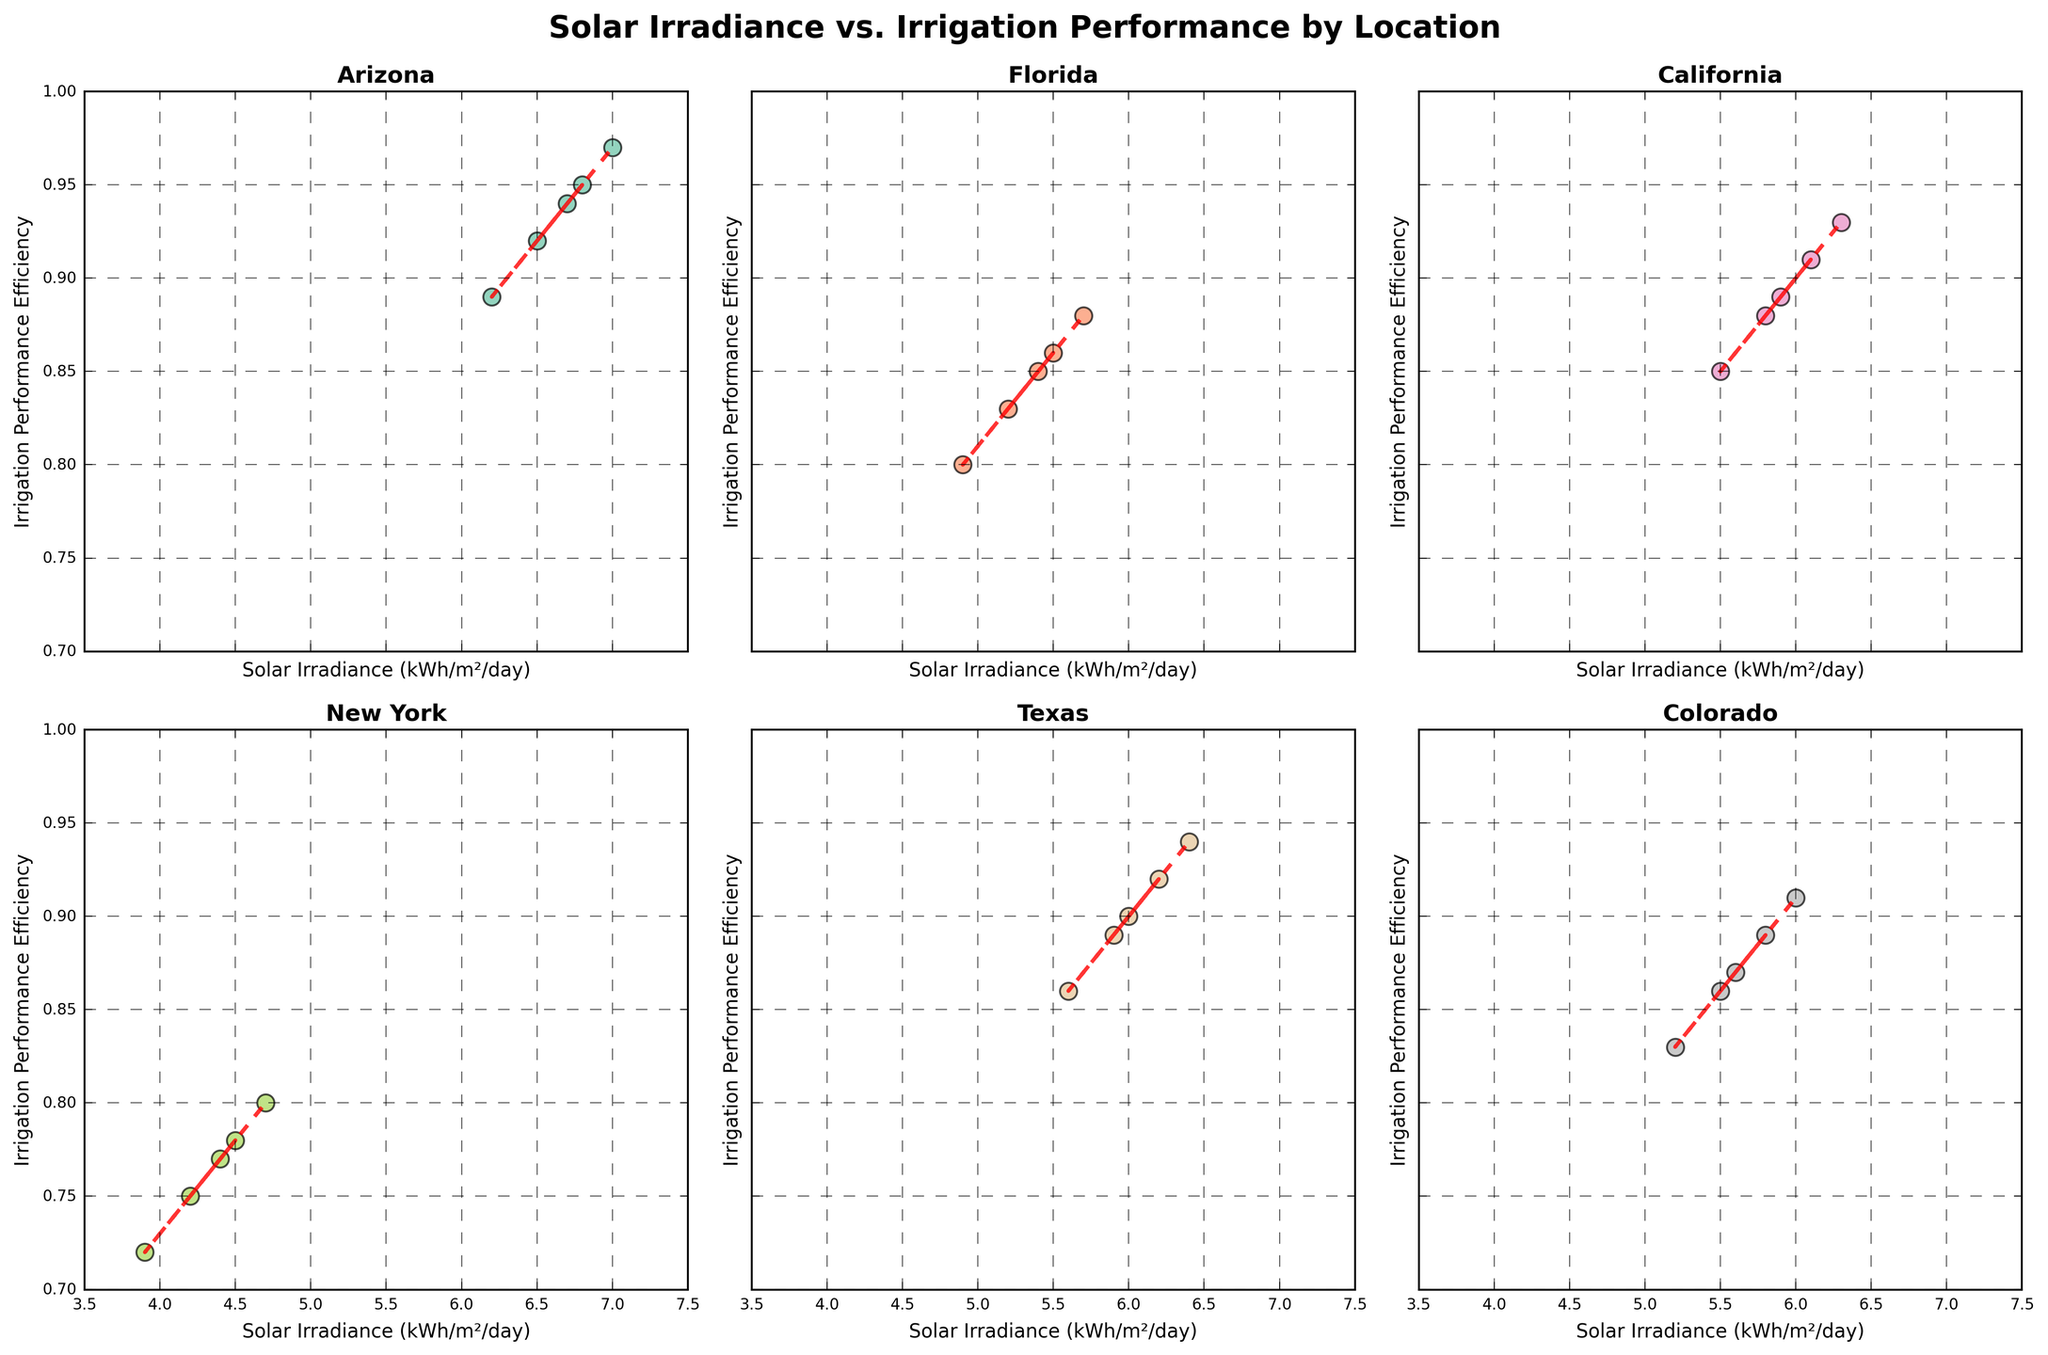Which location shows the highest range of irrigation performance efficiency? The highest range of irrigation performance efficiency is determined by finding the difference between the maximum and minimum efficiency values for each location. Arizona has a range from 0.89 to 0.97, which is 0.08, and the other ranges for locations are less than this.
Answer: Arizona In which location does the solar irradiance correlate most strongly with irrigation performance efficiency? The correlation strength can be judged by the slope and closeness of the points to the trend line. Arizona shows a strong positive trend with points close to the trend line.
Answer: Arizona Which location has the lowest minimum value of solar irradiance? Checking each subplot, New York shows values starting as low as 3.9 kWh/m²/day, which is the lowest minimum among all locations.
Answer: New York Which location exhibits the least variability in irrigation performance efficiency? Least variability can be assessed by observing the spread of the irrigation performance efficiency values. California shows closely packed efficiency values between 0.85 and 0.93, indicating the least variability.
Answer: California Compare the average solar irradiance between Florida and Colorado. Which one is higher? To compare the average solar irradiance, we calculate the mean value of solar irradiance for both locations. For Florida, it is (5.2+5.5+4.9+5.7+5.4)/5 = 5.34 kWh/m²/day. For Colorado, it is (5.5+5.8+5.2+6.0+5.6)/5 = 5.62 kWh/m²/day. Hence, Colorado has a higher average solar irradiance.
Answer: Colorado Which location has the steepest trend line (indicating the strongest linear relationship)? By observing the angle and steepness of the trend lines in the subplots, Arizona's trend line appears the steepest, suggesting Arizona has the strongest linear relationship.
Answer: Arizona Which locations have overlapping ranges of irrigation performance efficiency? Looking at the irrigation performance efficiency values, Florida and California have overlapping ranges (0.80 to 0.88 for Florida and 0.85 to 0.93 for California).
Answer: Florida and California How does the trend line for New York differ from that of Texas? New York's trend line has a gentle incline, indicating a weaker positive relationship, while Texas shows a steeper trend line, indicating a stronger positive correlation between solar irradiance and irrigation efficiency.
Answer: New York: Gentle incline, Texas: Steeper Identify the location with the highest maximum value of irrigation performance efficiency. By evaluating the highest values in each subplot, Arizona has the highest maximum irrigation performance efficiency at 0.97.
Answer: Arizona 